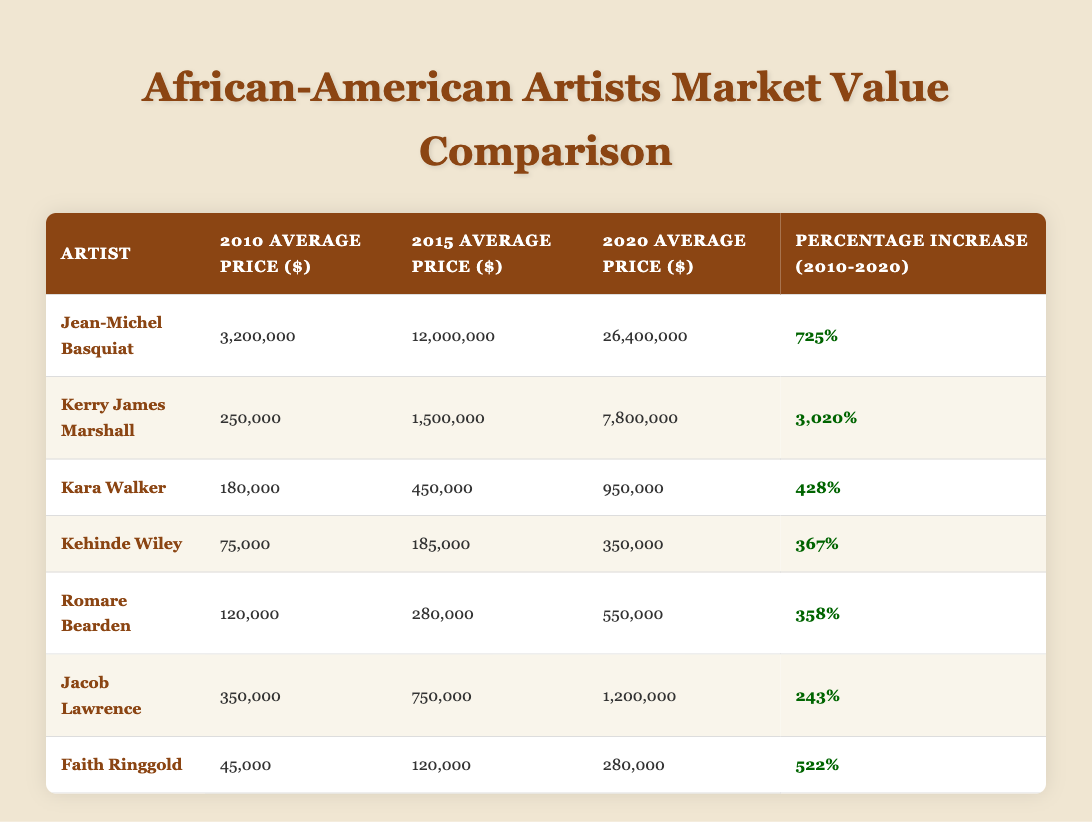What is the average price of Jean-Michel Basquiat's work in 2020? The table shows that the average price for Jean-Michel Basquiat's artwork in 2020 is listed as 26,400,000 dollars.
Answer: 26,400,000 Which artist experienced the highest percentage increase in market value from 2010 to 2020? To find this, we examine the percentage increase column. Kerry James Marshall has the highest percentage increase at 3020%.
Answer: Kerry James Marshall What was the average price of Kehinde Wiley's works in 2015? According to the table, Kehinde Wiley’s average price in 2015 is 185,000 dollars.
Answer: 185,000 Is it true that Kara Walker's average price in 2020 was less than one million dollars? The table indicates that Kara Walker's average price in 2020 is 950,000 dollars, which is less than one million. Therefore, the answer is true.
Answer: True What is the total average price for all artists in 2010? To find this, we sum the average prices in 2010: 3,200,000 + 250,000 + 180,000 + 75,000 + 120,000 + 350,000 + 45,000 = 3,970,000 dollars.
Answer: 3,970,000 How does the average price of Faith Ringgold's artwork in 2020 compare to that of Jacob Lawrence in the same year? Faith Ringgold's average price in 2020 is 280,000 dollars, while Jacob Lawrence's is 1,200,000 dollars. Since 280,000 is significantly lower than 1,200,000, Faith Ringgold's is lower than Jacob Lawrence's.
Answer: Lower What was the average price of works by Romare Bearden in 2015? The table lists that Romare Bearden’s average price in 2015 is 280,000 dollars.
Answer: 280,000 Which artist had an average price of 45,000 dollars in 2010? By checking the table, we see that Faith Ringgold had an average price of 45,000 dollars in 2010.
Answer: Faith Ringgold 